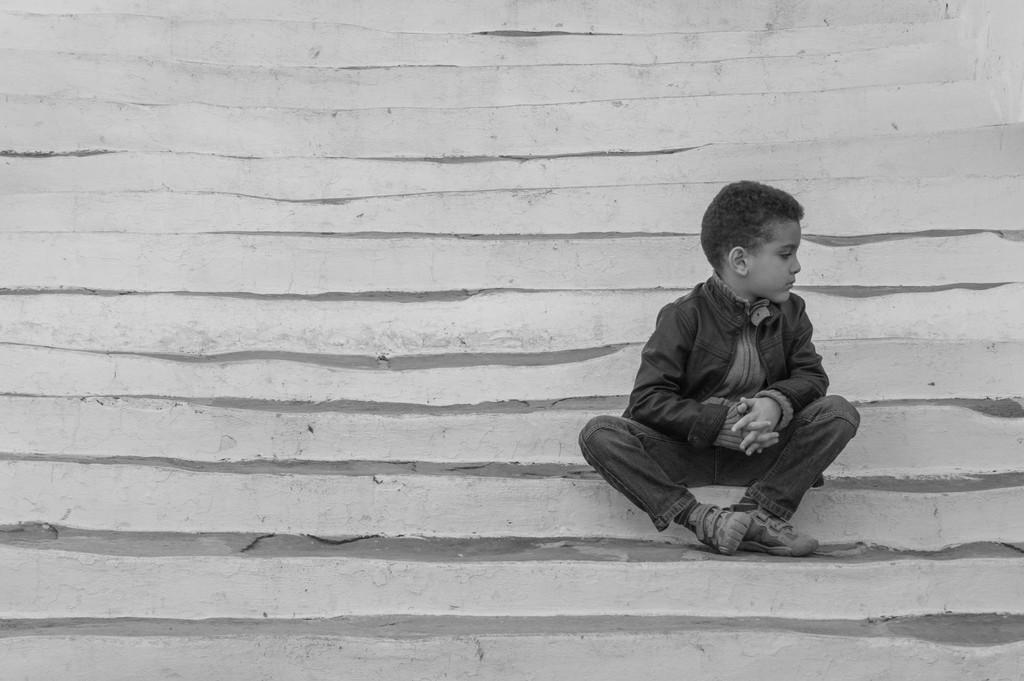Who is the main subject in the image? There is a small boy in the image. What is the small boy doing in the image? The small boy is sitting on the stairs. Where are the stairs located in the image? The stairs are in the foreground area of the image. What type of flowers can be seen growing near the small boy? There are no flowers present in the image; it only features the small boy sitting on the stairs. 